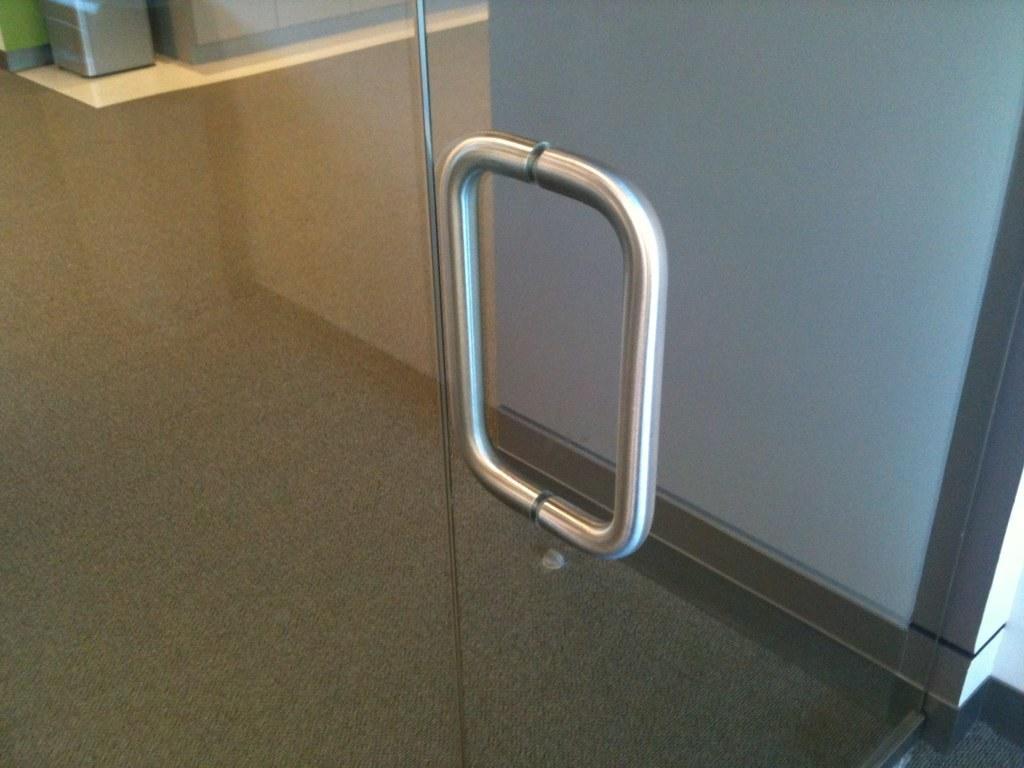Describe this image in one or two sentences. In this image in the foreground there is a glass door, with a metal handle. In the background on a table there is something. 